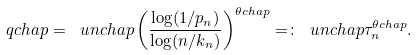<formula> <loc_0><loc_0><loc_500><loc_500>\ q c h a p = \ u n c h a p \left ( \frac { \log ( 1 / p _ { n } ) } { \log ( n / k _ { n } ) } \right ) ^ { \theta c h a p } = \colon \ u n c h a p \tau _ { n } ^ { \theta c h a p } .</formula> 